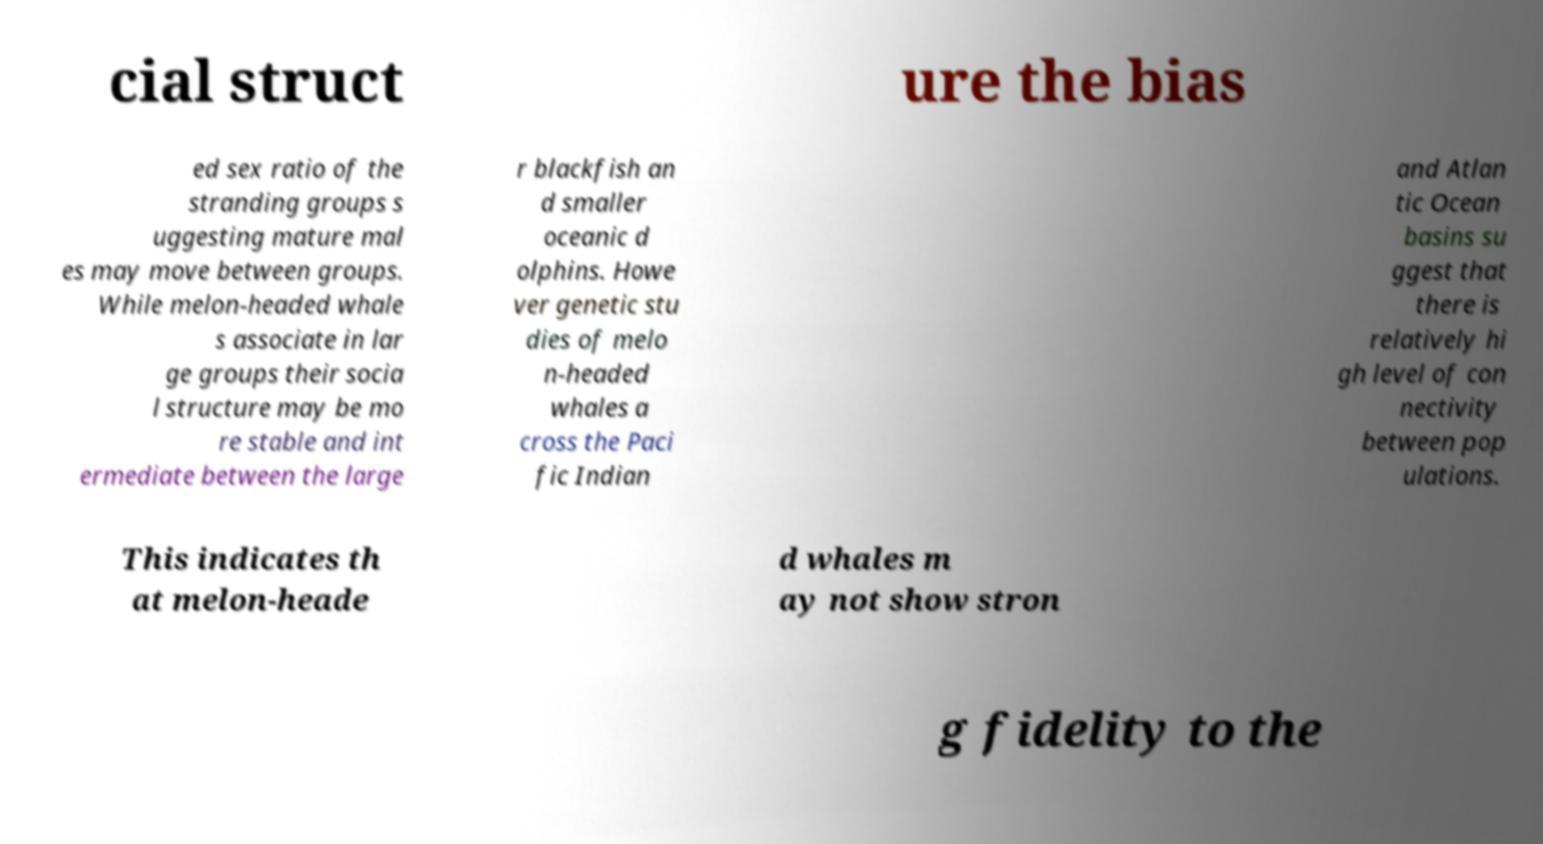I need the written content from this picture converted into text. Can you do that? cial struct ure the bias ed sex ratio of the stranding groups s uggesting mature mal es may move between groups. While melon-headed whale s associate in lar ge groups their socia l structure may be mo re stable and int ermediate between the large r blackfish an d smaller oceanic d olphins. Howe ver genetic stu dies of melo n-headed whales a cross the Paci fic Indian and Atlan tic Ocean basins su ggest that there is relatively hi gh level of con nectivity between pop ulations. This indicates th at melon-heade d whales m ay not show stron g fidelity to the 